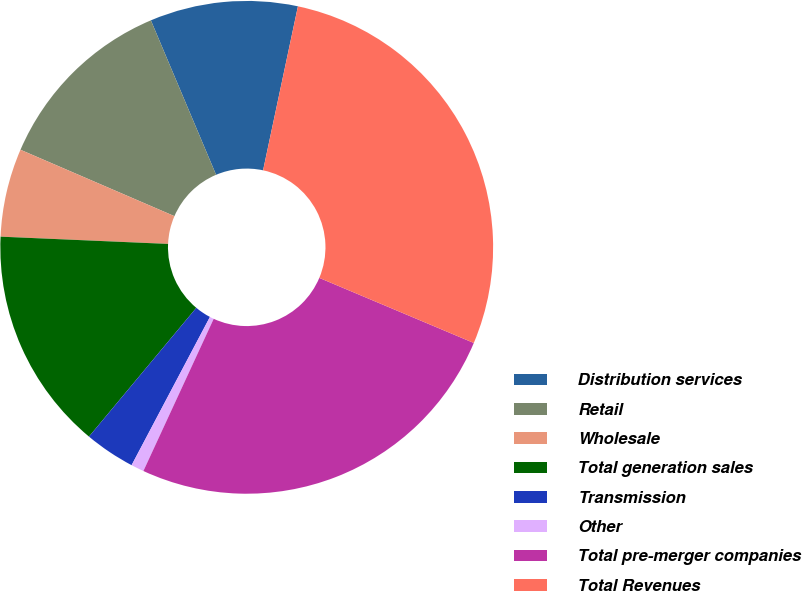Convert chart. <chart><loc_0><loc_0><loc_500><loc_500><pie_chart><fcel>Distribution services<fcel>Retail<fcel>Wholesale<fcel>Total generation sales<fcel>Transmission<fcel>Other<fcel>Total pre-merger companies<fcel>Total Revenues<nl><fcel>9.69%<fcel>12.16%<fcel>5.79%<fcel>14.63%<fcel>3.32%<fcel>0.85%<fcel>25.54%<fcel>28.01%<nl></chart> 